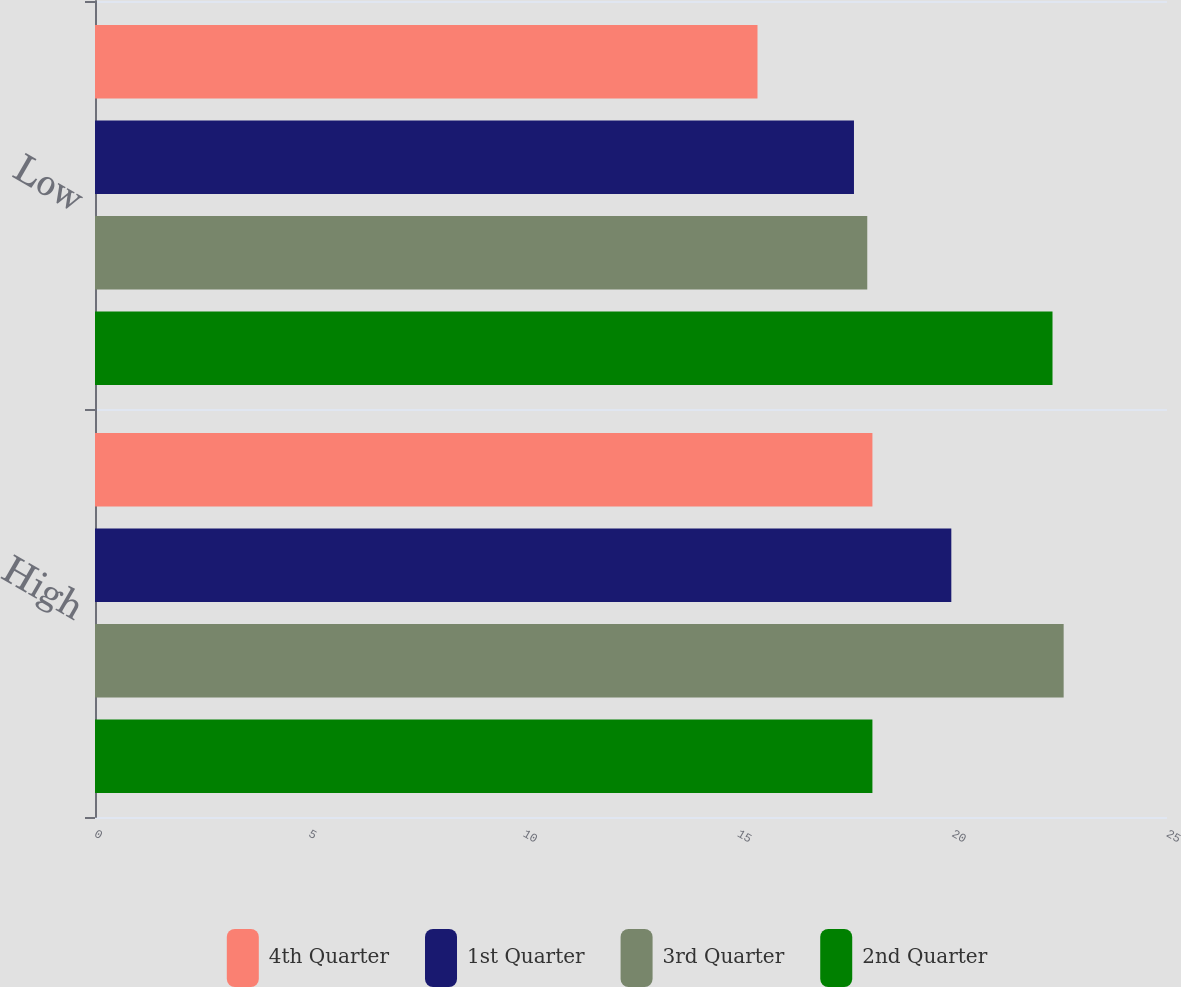<chart> <loc_0><loc_0><loc_500><loc_500><stacked_bar_chart><ecel><fcel>High<fcel>Low<nl><fcel>4th Quarter<fcel>18.13<fcel>15.45<nl><fcel>1st Quarter<fcel>19.97<fcel>17.7<nl><fcel>3rd Quarter<fcel>22.59<fcel>18.01<nl><fcel>2nd Quarter<fcel>18.13<fcel>22.33<nl></chart> 